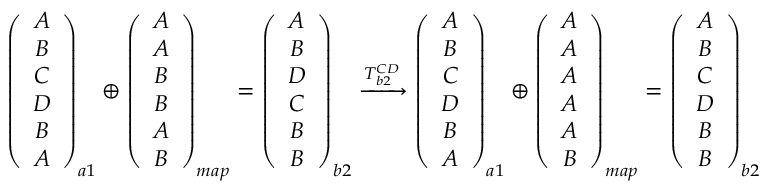Convert formula to latex. <formula><loc_0><loc_0><loc_500><loc_500>\begin{array} { r } { \left ( \begin{array} { c } { A } \\ { B } \\ { C } \\ { D } \\ { B } \\ { A } \end{array} \right ) _ { a 1 } \oplus \left ( \begin{array} { c } { A } \\ { A } \\ { B } \\ { B } \\ { A } \\ { B } \end{array} \right ) _ { m a p } = \left ( \begin{array} { c } { A } \\ { B } \\ { D } \\ { C } \\ { B } \\ { B } \end{array} \right ) _ { b 2 } \xrightarrow { T _ { b 2 } ^ { C D } } \left ( \begin{array} { c } { A } \\ { B } \\ { C } \\ { D } \\ { B } \\ { A } \end{array} \right ) _ { a 1 } \oplus \left ( \begin{array} { c } { A } \\ { A } \\ { A } \\ { A } \\ { A } \\ { B } \end{array} \right ) _ { m a p } = \left ( \begin{array} { c } { A } \\ { B } \\ { C } \\ { D } \\ { B } \\ { B } \end{array} \right ) _ { b 2 } } \end{array}</formula> 